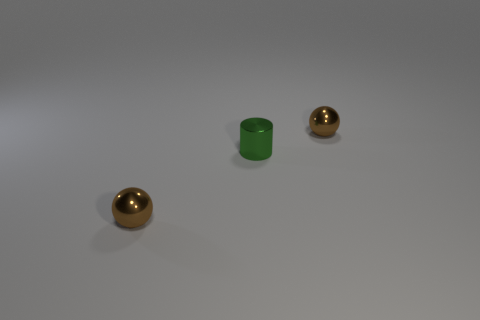What might be the purpose of these objects? These objects could have decorative purposes, given their shiny and polished appearance. The green cylinder could be a container or a piece of modern art, while the spherical objects might serve as ornamental accents in a home or office setting. 